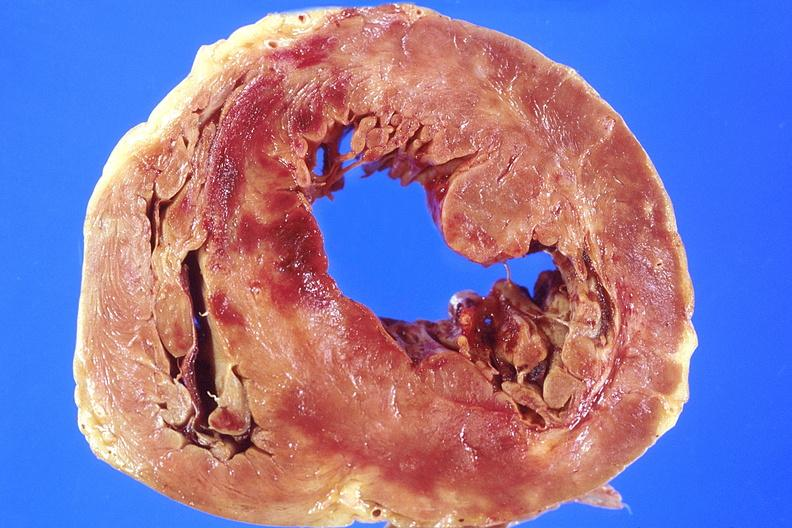does omentum show heart, acute myocardial infarction, anterior wall?
Answer the question using a single word or phrase. No 